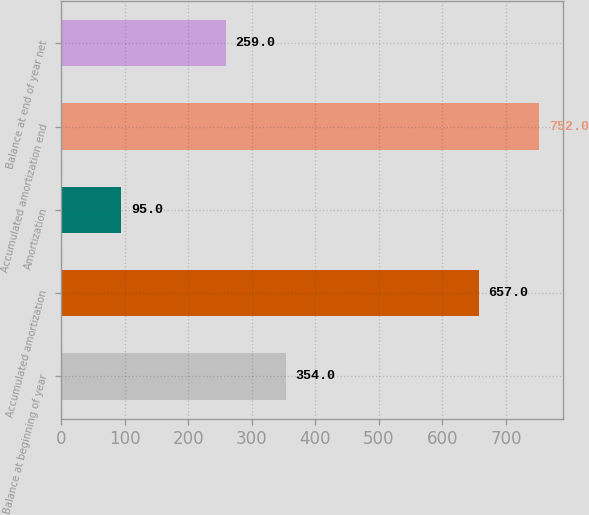Convert chart to OTSL. <chart><loc_0><loc_0><loc_500><loc_500><bar_chart><fcel>Balance at beginning of year<fcel>Accumulated amortization<fcel>Amortization<fcel>Accumulated amortization end<fcel>Balance at end of year net<nl><fcel>354<fcel>657<fcel>95<fcel>752<fcel>259<nl></chart> 